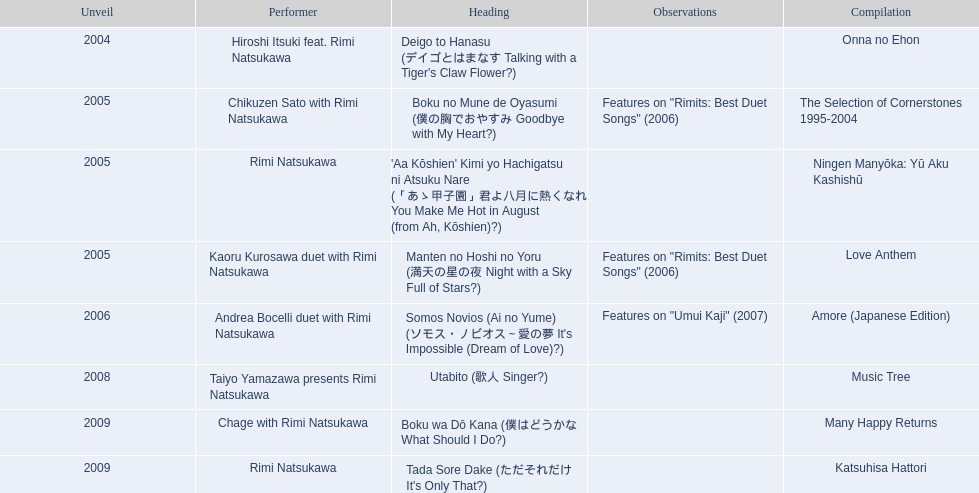Which title of the rimi natsukawa discography was released in the 2004? Deigo to Hanasu (デイゴとはまなす Talking with a Tiger's Claw Flower?). Which title has notes that features on/rimits. best duet songs\2006 Manten no Hoshi no Yoru (満天の星の夜 Night with a Sky Full of Stars?). Which title share the same notes as night with a sky full of stars? Boku no Mune de Oyasumi (僕の胸でおやすみ Goodbye with My Heart?). 